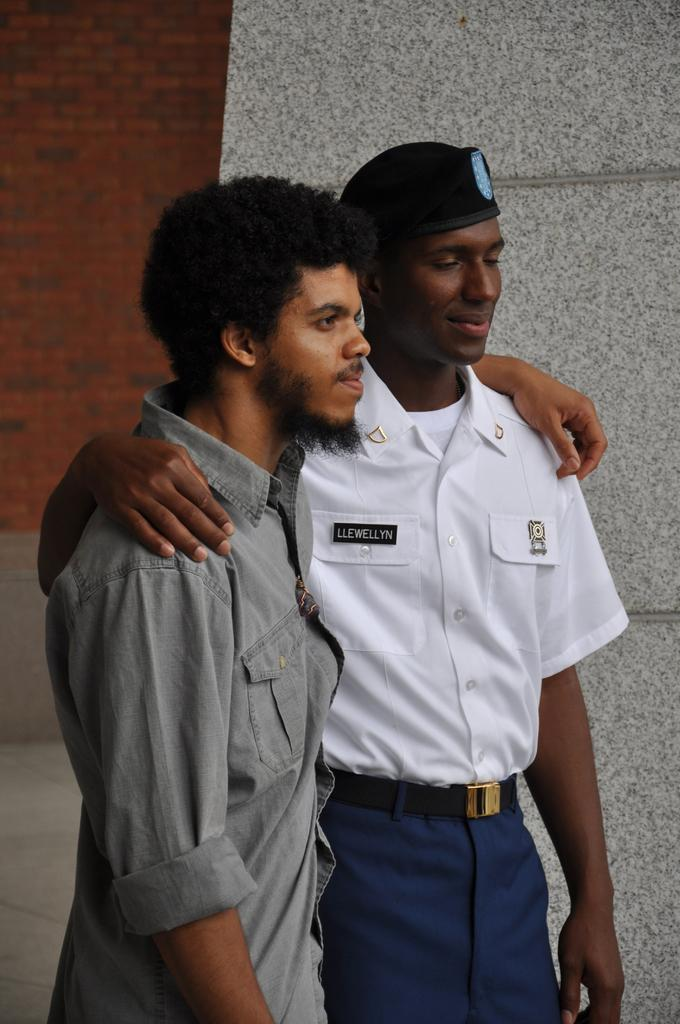How many people are in the image? There are two men in the image. What are the men doing in the image? The men are standing beside each other with their hands on each other's shoulders. What can be seen in the background of the image? There is a wall in the background of the image. What type of steel is visible in the image? There is no steel present in the image. How many pages are visible in the image? There are no pages present in the image. 